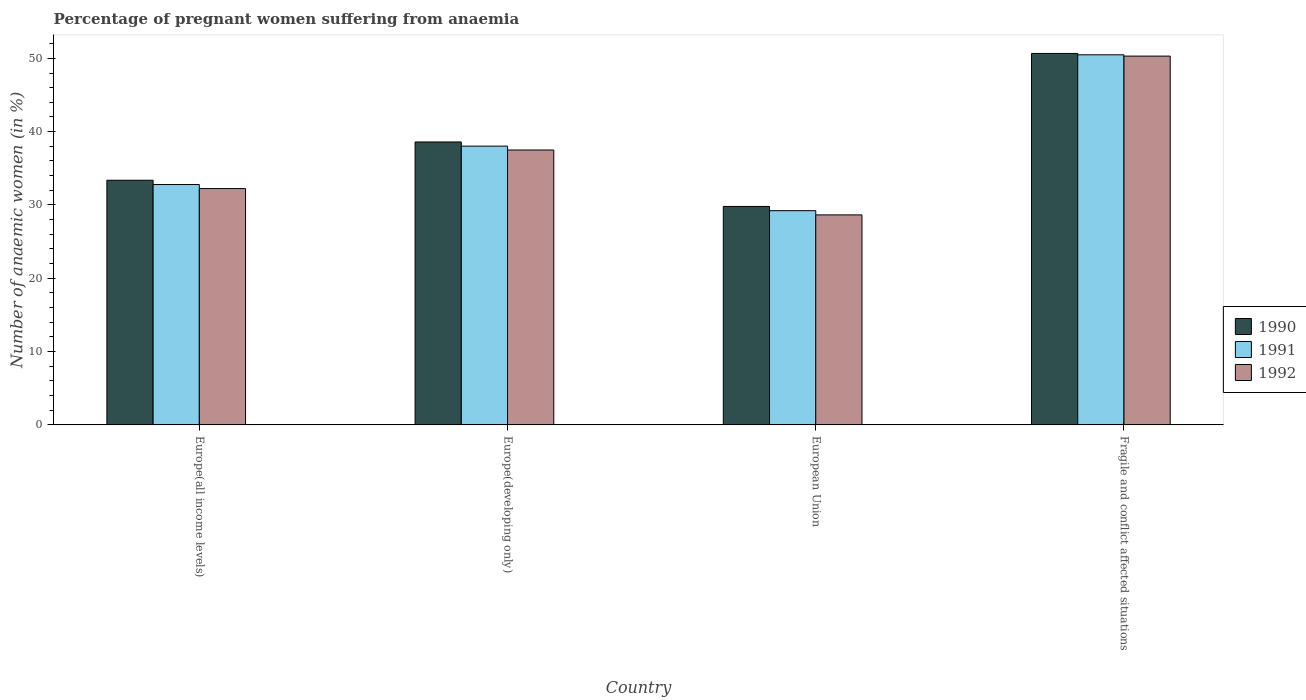How many different coloured bars are there?
Your answer should be very brief. 3. How many groups of bars are there?
Provide a succinct answer. 4. Are the number of bars per tick equal to the number of legend labels?
Your answer should be compact. Yes. How many bars are there on the 3rd tick from the left?
Your response must be concise. 3. What is the label of the 1st group of bars from the left?
Keep it short and to the point. Europe(all income levels). In how many cases, is the number of bars for a given country not equal to the number of legend labels?
Give a very brief answer. 0. What is the number of anaemic women in 1992 in Europe(developing only)?
Your answer should be compact. 37.5. Across all countries, what is the maximum number of anaemic women in 1991?
Your answer should be very brief. 50.48. Across all countries, what is the minimum number of anaemic women in 1990?
Your response must be concise. 29.8. In which country was the number of anaemic women in 1991 maximum?
Give a very brief answer. Fragile and conflict affected situations. What is the total number of anaemic women in 1990 in the graph?
Your answer should be very brief. 152.43. What is the difference between the number of anaemic women in 1990 in European Union and that in Fragile and conflict affected situations?
Your answer should be very brief. -20.87. What is the difference between the number of anaemic women in 1990 in Europe(developing only) and the number of anaemic women in 1992 in Fragile and conflict affected situations?
Provide a succinct answer. -11.71. What is the average number of anaemic women in 1992 per country?
Your answer should be very brief. 37.17. What is the difference between the number of anaemic women of/in 1992 and number of anaemic women of/in 1990 in Fragile and conflict affected situations?
Provide a succinct answer. -0.36. What is the ratio of the number of anaemic women in 1991 in European Union to that in Fragile and conflict affected situations?
Keep it short and to the point. 0.58. What is the difference between the highest and the second highest number of anaemic women in 1992?
Provide a succinct answer. -18.07. What is the difference between the highest and the lowest number of anaemic women in 1990?
Keep it short and to the point. 20.87. Is the sum of the number of anaemic women in 1990 in European Union and Fragile and conflict affected situations greater than the maximum number of anaemic women in 1991 across all countries?
Your response must be concise. Yes. What does the 2nd bar from the right in Europe(all income levels) represents?
Offer a terse response. 1991. Is it the case that in every country, the sum of the number of anaemic women in 1992 and number of anaemic women in 1990 is greater than the number of anaemic women in 1991?
Provide a succinct answer. Yes. How many bars are there?
Give a very brief answer. 12. How many countries are there in the graph?
Offer a very short reply. 4. What is the difference between two consecutive major ticks on the Y-axis?
Your answer should be compact. 10. Does the graph contain any zero values?
Ensure brevity in your answer.  No. Does the graph contain grids?
Your response must be concise. No. Where does the legend appear in the graph?
Offer a terse response. Center right. How are the legend labels stacked?
Make the answer very short. Vertical. What is the title of the graph?
Offer a terse response. Percentage of pregnant women suffering from anaemia. Does "1992" appear as one of the legend labels in the graph?
Make the answer very short. Yes. What is the label or title of the X-axis?
Offer a terse response. Country. What is the label or title of the Y-axis?
Your response must be concise. Number of anaemic women (in %). What is the Number of anaemic women (in %) of 1990 in Europe(all income levels)?
Ensure brevity in your answer.  33.37. What is the Number of anaemic women (in %) of 1991 in Europe(all income levels)?
Keep it short and to the point. 32.79. What is the Number of anaemic women (in %) of 1992 in Europe(all income levels)?
Your answer should be compact. 32.24. What is the Number of anaemic women (in %) in 1990 in Europe(developing only)?
Keep it short and to the point. 38.59. What is the Number of anaemic women (in %) of 1991 in Europe(developing only)?
Offer a very short reply. 38.02. What is the Number of anaemic women (in %) of 1992 in Europe(developing only)?
Provide a short and direct response. 37.5. What is the Number of anaemic women (in %) of 1990 in European Union?
Give a very brief answer. 29.8. What is the Number of anaemic women (in %) in 1991 in European Union?
Your response must be concise. 29.22. What is the Number of anaemic women (in %) of 1992 in European Union?
Your response must be concise. 28.65. What is the Number of anaemic women (in %) in 1990 in Fragile and conflict affected situations?
Give a very brief answer. 50.67. What is the Number of anaemic women (in %) in 1991 in Fragile and conflict affected situations?
Your response must be concise. 50.48. What is the Number of anaemic women (in %) of 1992 in Fragile and conflict affected situations?
Ensure brevity in your answer.  50.31. Across all countries, what is the maximum Number of anaemic women (in %) in 1990?
Your response must be concise. 50.67. Across all countries, what is the maximum Number of anaemic women (in %) in 1991?
Your response must be concise. 50.48. Across all countries, what is the maximum Number of anaemic women (in %) in 1992?
Provide a short and direct response. 50.31. Across all countries, what is the minimum Number of anaemic women (in %) of 1990?
Provide a short and direct response. 29.8. Across all countries, what is the minimum Number of anaemic women (in %) of 1991?
Make the answer very short. 29.22. Across all countries, what is the minimum Number of anaemic women (in %) in 1992?
Your answer should be compact. 28.65. What is the total Number of anaemic women (in %) of 1990 in the graph?
Ensure brevity in your answer.  152.43. What is the total Number of anaemic women (in %) in 1991 in the graph?
Make the answer very short. 150.51. What is the total Number of anaemic women (in %) in 1992 in the graph?
Give a very brief answer. 148.69. What is the difference between the Number of anaemic women (in %) in 1990 in Europe(all income levels) and that in Europe(developing only)?
Make the answer very short. -5.22. What is the difference between the Number of anaemic women (in %) in 1991 in Europe(all income levels) and that in Europe(developing only)?
Keep it short and to the point. -5.24. What is the difference between the Number of anaemic women (in %) in 1992 in Europe(all income levels) and that in Europe(developing only)?
Offer a terse response. -5.26. What is the difference between the Number of anaemic women (in %) of 1990 in Europe(all income levels) and that in European Union?
Keep it short and to the point. 3.57. What is the difference between the Number of anaemic women (in %) of 1991 in Europe(all income levels) and that in European Union?
Your answer should be very brief. 3.57. What is the difference between the Number of anaemic women (in %) of 1992 in Europe(all income levels) and that in European Union?
Keep it short and to the point. 3.59. What is the difference between the Number of anaemic women (in %) in 1990 in Europe(all income levels) and that in Fragile and conflict affected situations?
Your answer should be very brief. -17.29. What is the difference between the Number of anaemic women (in %) of 1991 in Europe(all income levels) and that in Fragile and conflict affected situations?
Give a very brief answer. -17.7. What is the difference between the Number of anaemic women (in %) in 1992 in Europe(all income levels) and that in Fragile and conflict affected situations?
Give a very brief answer. -18.07. What is the difference between the Number of anaemic women (in %) of 1990 in Europe(developing only) and that in European Union?
Your answer should be very brief. 8.79. What is the difference between the Number of anaemic women (in %) of 1991 in Europe(developing only) and that in European Union?
Your answer should be compact. 8.8. What is the difference between the Number of anaemic women (in %) in 1992 in Europe(developing only) and that in European Union?
Your response must be concise. 8.85. What is the difference between the Number of anaemic women (in %) of 1990 in Europe(developing only) and that in Fragile and conflict affected situations?
Offer a terse response. -12.07. What is the difference between the Number of anaemic women (in %) of 1991 in Europe(developing only) and that in Fragile and conflict affected situations?
Your answer should be compact. -12.46. What is the difference between the Number of anaemic women (in %) in 1992 in Europe(developing only) and that in Fragile and conflict affected situations?
Keep it short and to the point. -12.81. What is the difference between the Number of anaemic women (in %) in 1990 in European Union and that in Fragile and conflict affected situations?
Your response must be concise. -20.87. What is the difference between the Number of anaemic women (in %) of 1991 in European Union and that in Fragile and conflict affected situations?
Offer a terse response. -21.26. What is the difference between the Number of anaemic women (in %) of 1992 in European Union and that in Fragile and conflict affected situations?
Ensure brevity in your answer.  -21.66. What is the difference between the Number of anaemic women (in %) in 1990 in Europe(all income levels) and the Number of anaemic women (in %) in 1991 in Europe(developing only)?
Offer a terse response. -4.65. What is the difference between the Number of anaemic women (in %) of 1990 in Europe(all income levels) and the Number of anaemic women (in %) of 1992 in Europe(developing only)?
Offer a terse response. -4.13. What is the difference between the Number of anaemic women (in %) in 1991 in Europe(all income levels) and the Number of anaemic women (in %) in 1992 in Europe(developing only)?
Keep it short and to the point. -4.71. What is the difference between the Number of anaemic women (in %) of 1990 in Europe(all income levels) and the Number of anaemic women (in %) of 1991 in European Union?
Make the answer very short. 4.15. What is the difference between the Number of anaemic women (in %) of 1990 in Europe(all income levels) and the Number of anaemic women (in %) of 1992 in European Union?
Your response must be concise. 4.73. What is the difference between the Number of anaemic women (in %) of 1991 in Europe(all income levels) and the Number of anaemic women (in %) of 1992 in European Union?
Your answer should be very brief. 4.14. What is the difference between the Number of anaemic women (in %) in 1990 in Europe(all income levels) and the Number of anaemic women (in %) in 1991 in Fragile and conflict affected situations?
Offer a terse response. -17.11. What is the difference between the Number of anaemic women (in %) in 1990 in Europe(all income levels) and the Number of anaemic women (in %) in 1992 in Fragile and conflict affected situations?
Offer a terse response. -16.93. What is the difference between the Number of anaemic women (in %) in 1991 in Europe(all income levels) and the Number of anaemic women (in %) in 1992 in Fragile and conflict affected situations?
Your answer should be very brief. -17.52. What is the difference between the Number of anaemic women (in %) of 1990 in Europe(developing only) and the Number of anaemic women (in %) of 1991 in European Union?
Offer a terse response. 9.37. What is the difference between the Number of anaemic women (in %) of 1990 in Europe(developing only) and the Number of anaemic women (in %) of 1992 in European Union?
Make the answer very short. 9.95. What is the difference between the Number of anaemic women (in %) in 1991 in Europe(developing only) and the Number of anaemic women (in %) in 1992 in European Union?
Make the answer very short. 9.38. What is the difference between the Number of anaemic women (in %) in 1990 in Europe(developing only) and the Number of anaemic women (in %) in 1991 in Fragile and conflict affected situations?
Your response must be concise. -11.89. What is the difference between the Number of anaemic women (in %) of 1990 in Europe(developing only) and the Number of anaemic women (in %) of 1992 in Fragile and conflict affected situations?
Your answer should be compact. -11.71. What is the difference between the Number of anaemic women (in %) in 1991 in Europe(developing only) and the Number of anaemic women (in %) in 1992 in Fragile and conflict affected situations?
Your answer should be very brief. -12.28. What is the difference between the Number of anaemic women (in %) in 1990 in European Union and the Number of anaemic women (in %) in 1991 in Fragile and conflict affected situations?
Your answer should be compact. -20.68. What is the difference between the Number of anaemic women (in %) in 1990 in European Union and the Number of anaemic women (in %) in 1992 in Fragile and conflict affected situations?
Give a very brief answer. -20.51. What is the difference between the Number of anaemic women (in %) in 1991 in European Union and the Number of anaemic women (in %) in 1992 in Fragile and conflict affected situations?
Your response must be concise. -21.08. What is the average Number of anaemic women (in %) of 1990 per country?
Offer a very short reply. 38.11. What is the average Number of anaemic women (in %) of 1991 per country?
Offer a terse response. 37.63. What is the average Number of anaemic women (in %) of 1992 per country?
Ensure brevity in your answer.  37.17. What is the difference between the Number of anaemic women (in %) in 1990 and Number of anaemic women (in %) in 1991 in Europe(all income levels)?
Offer a very short reply. 0.59. What is the difference between the Number of anaemic women (in %) in 1990 and Number of anaemic women (in %) in 1992 in Europe(all income levels)?
Your response must be concise. 1.14. What is the difference between the Number of anaemic women (in %) in 1991 and Number of anaemic women (in %) in 1992 in Europe(all income levels)?
Your answer should be compact. 0.55. What is the difference between the Number of anaemic women (in %) in 1990 and Number of anaemic women (in %) in 1991 in Europe(developing only)?
Offer a terse response. 0.57. What is the difference between the Number of anaemic women (in %) of 1990 and Number of anaemic women (in %) of 1992 in Europe(developing only)?
Offer a very short reply. 1.1. What is the difference between the Number of anaemic women (in %) in 1991 and Number of anaemic women (in %) in 1992 in Europe(developing only)?
Give a very brief answer. 0.53. What is the difference between the Number of anaemic women (in %) of 1990 and Number of anaemic women (in %) of 1991 in European Union?
Give a very brief answer. 0.58. What is the difference between the Number of anaemic women (in %) in 1990 and Number of anaemic women (in %) in 1992 in European Union?
Your answer should be very brief. 1.15. What is the difference between the Number of anaemic women (in %) in 1991 and Number of anaemic women (in %) in 1992 in European Union?
Keep it short and to the point. 0.58. What is the difference between the Number of anaemic women (in %) of 1990 and Number of anaemic women (in %) of 1991 in Fragile and conflict affected situations?
Provide a succinct answer. 0.19. What is the difference between the Number of anaemic women (in %) of 1990 and Number of anaemic women (in %) of 1992 in Fragile and conflict affected situations?
Offer a terse response. 0.36. What is the difference between the Number of anaemic women (in %) in 1991 and Number of anaemic women (in %) in 1992 in Fragile and conflict affected situations?
Offer a terse response. 0.18. What is the ratio of the Number of anaemic women (in %) of 1990 in Europe(all income levels) to that in Europe(developing only)?
Your response must be concise. 0.86. What is the ratio of the Number of anaemic women (in %) of 1991 in Europe(all income levels) to that in Europe(developing only)?
Offer a terse response. 0.86. What is the ratio of the Number of anaemic women (in %) of 1992 in Europe(all income levels) to that in Europe(developing only)?
Offer a terse response. 0.86. What is the ratio of the Number of anaemic women (in %) of 1990 in Europe(all income levels) to that in European Union?
Make the answer very short. 1.12. What is the ratio of the Number of anaemic women (in %) in 1991 in Europe(all income levels) to that in European Union?
Provide a short and direct response. 1.12. What is the ratio of the Number of anaemic women (in %) of 1992 in Europe(all income levels) to that in European Union?
Make the answer very short. 1.13. What is the ratio of the Number of anaemic women (in %) in 1990 in Europe(all income levels) to that in Fragile and conflict affected situations?
Give a very brief answer. 0.66. What is the ratio of the Number of anaemic women (in %) in 1991 in Europe(all income levels) to that in Fragile and conflict affected situations?
Provide a succinct answer. 0.65. What is the ratio of the Number of anaemic women (in %) in 1992 in Europe(all income levels) to that in Fragile and conflict affected situations?
Make the answer very short. 0.64. What is the ratio of the Number of anaemic women (in %) of 1990 in Europe(developing only) to that in European Union?
Provide a short and direct response. 1.3. What is the ratio of the Number of anaemic women (in %) in 1991 in Europe(developing only) to that in European Union?
Provide a succinct answer. 1.3. What is the ratio of the Number of anaemic women (in %) in 1992 in Europe(developing only) to that in European Union?
Offer a terse response. 1.31. What is the ratio of the Number of anaemic women (in %) of 1990 in Europe(developing only) to that in Fragile and conflict affected situations?
Make the answer very short. 0.76. What is the ratio of the Number of anaemic women (in %) of 1991 in Europe(developing only) to that in Fragile and conflict affected situations?
Ensure brevity in your answer.  0.75. What is the ratio of the Number of anaemic women (in %) of 1992 in Europe(developing only) to that in Fragile and conflict affected situations?
Ensure brevity in your answer.  0.75. What is the ratio of the Number of anaemic women (in %) of 1990 in European Union to that in Fragile and conflict affected situations?
Your answer should be compact. 0.59. What is the ratio of the Number of anaemic women (in %) in 1991 in European Union to that in Fragile and conflict affected situations?
Offer a very short reply. 0.58. What is the ratio of the Number of anaemic women (in %) in 1992 in European Union to that in Fragile and conflict affected situations?
Your response must be concise. 0.57. What is the difference between the highest and the second highest Number of anaemic women (in %) in 1990?
Make the answer very short. 12.07. What is the difference between the highest and the second highest Number of anaemic women (in %) in 1991?
Provide a short and direct response. 12.46. What is the difference between the highest and the second highest Number of anaemic women (in %) of 1992?
Ensure brevity in your answer.  12.81. What is the difference between the highest and the lowest Number of anaemic women (in %) in 1990?
Offer a terse response. 20.87. What is the difference between the highest and the lowest Number of anaemic women (in %) of 1991?
Your answer should be very brief. 21.26. What is the difference between the highest and the lowest Number of anaemic women (in %) in 1992?
Ensure brevity in your answer.  21.66. 